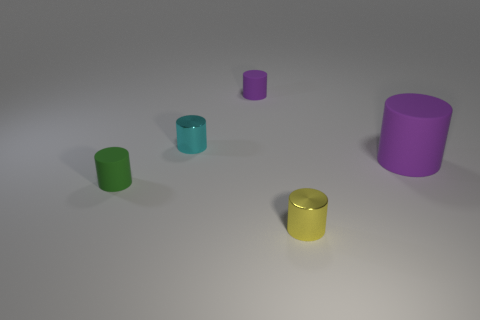What could be the purpose of these cylindrical objects? While the image does not provide enough context to ascertain their purpose definitively, these objects could be conceptual models, decorations, or part of a color and size recognition educational tool. If these cylinders were to be used in a game, what kind of game could it be? Given their simple shapes and variety of colors, they could be elements in a sorting or matching game where players organize them by color, size or another attribute, perhaps as a tabletop game for teaching children about colors and sizes. 